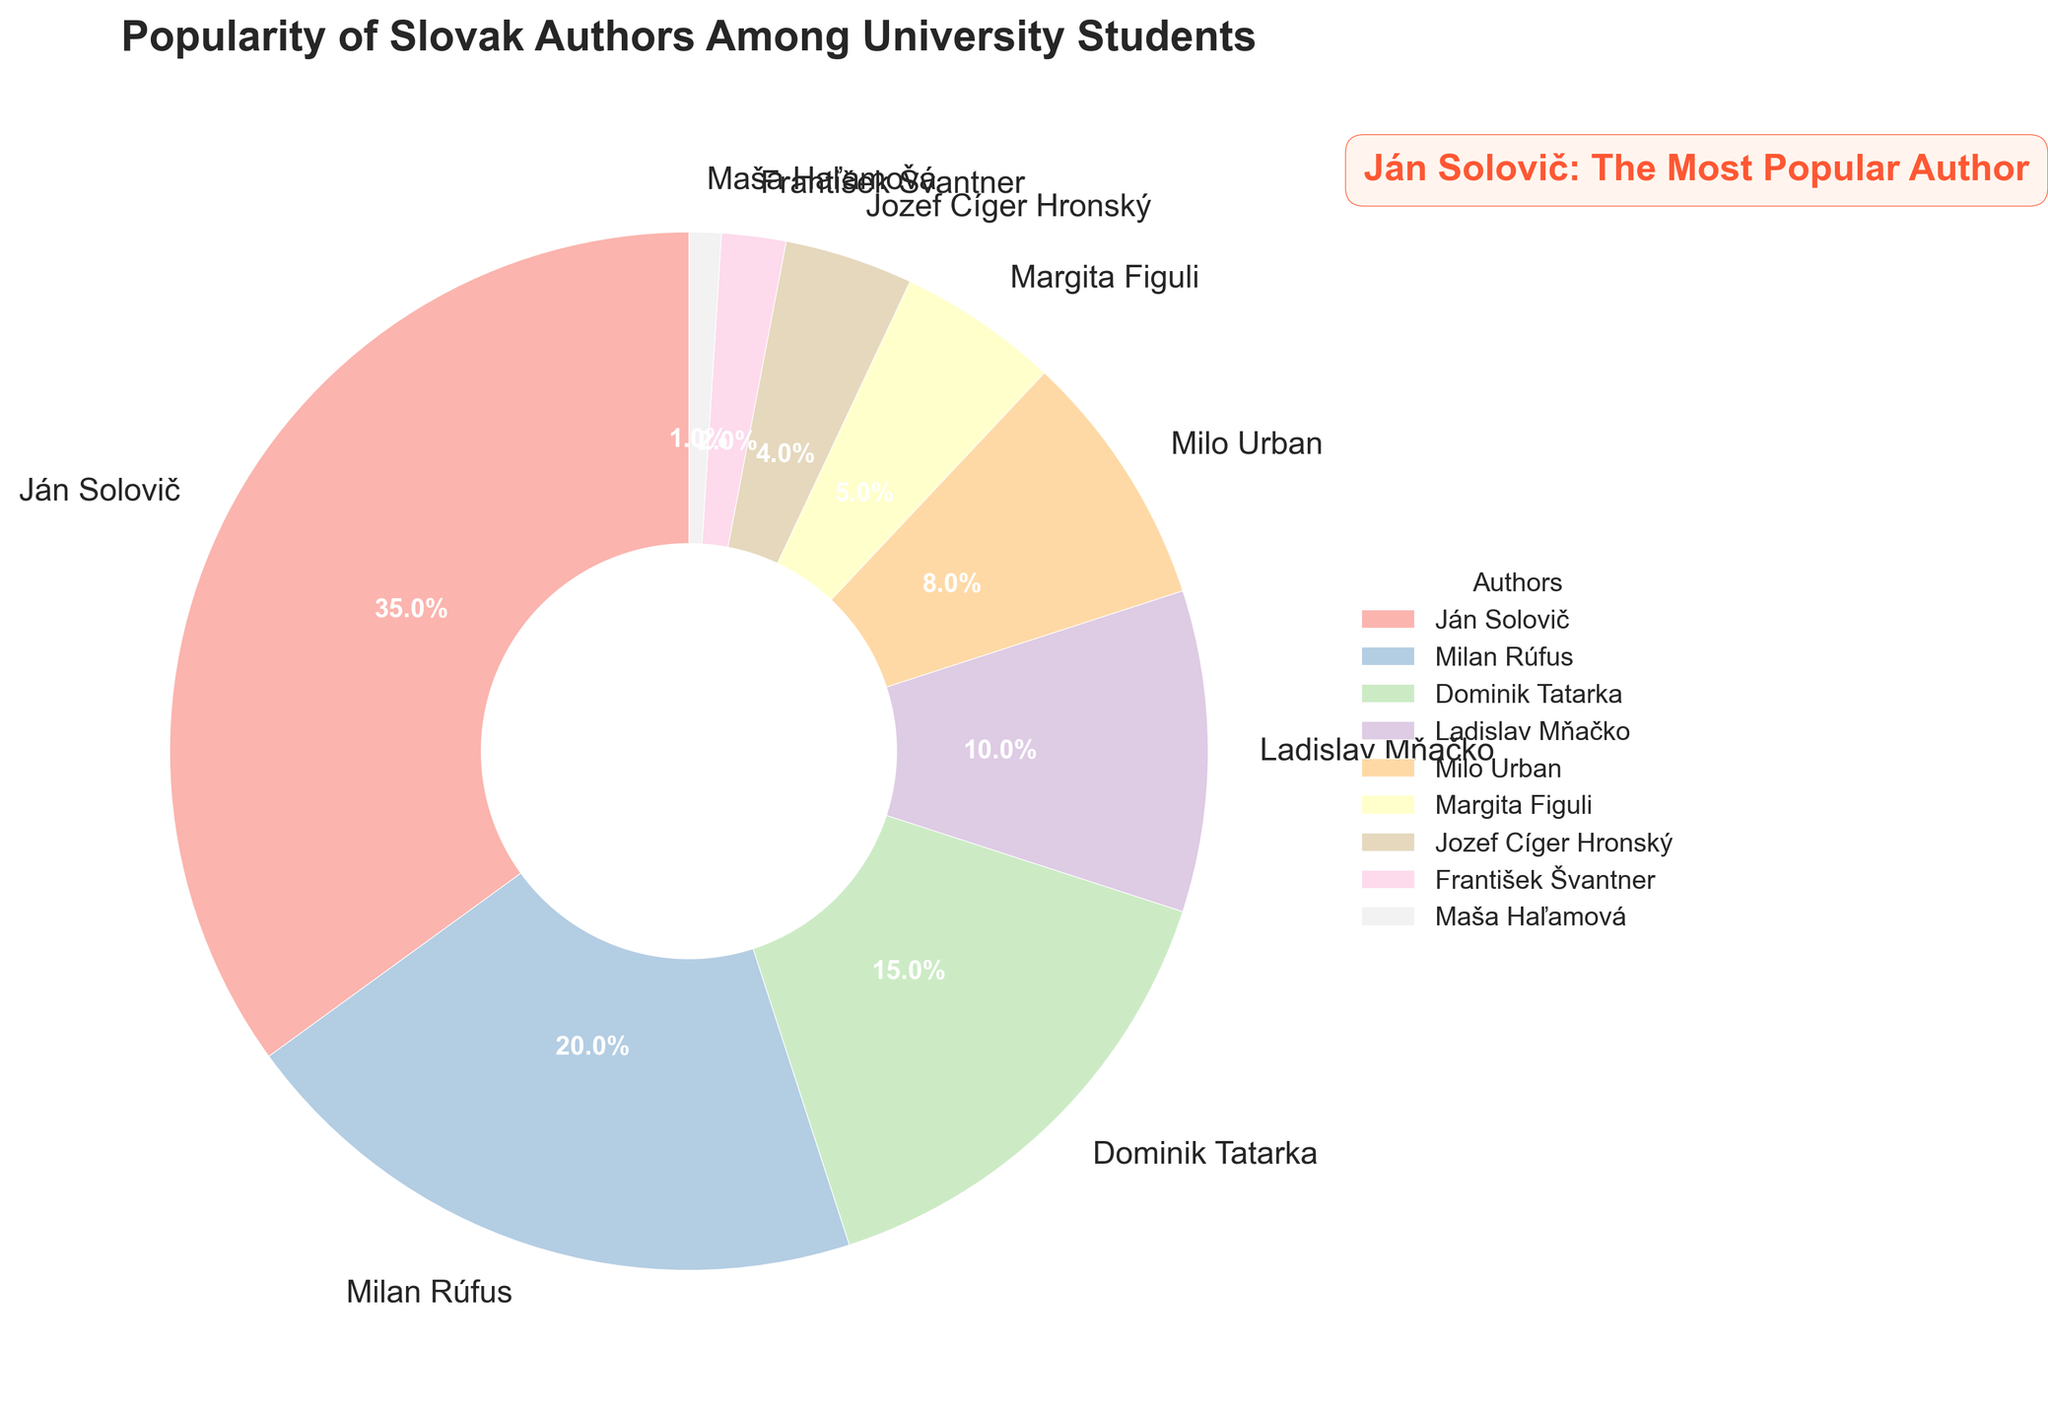What percentage of students prefer Ján Solovič? Ján Solovič has a wedge in the pie chart labeled with "35%", indicating that 35% of students prefer him.
Answer: 35% Who is the second most popular Slovak author among university students? The wedge with the next highest percentage after Ján Solovič is labeled "Milan Rúfus" with 20%.
Answer: Milan Rúfus What percentage of students prefer either Ján Solovič or Milan Rúfus? Add the percentages for Ján Solovič (35%) and Milan Rúfus (20%): 35% + 20% = 55%.
Answer: 55% How much more popular is Ján Solovič compared to Milo Urban? Ján Solovič has 35% and Milo Urban has 8%. The difference is 35% - 8% = 27%.
Answer: 27% Which author has the least popularity among students? The smallest wedge is labeled "Maša Haľamová" with 1%.
Answer: Maša Haľamová What is the combined popularity percentage of Dominik Tatarka and Ladislav Mňačko? Add the percentages for Dominik Tatarka (15%) and Ladislav Mňačko (10%): 15% + 10% = 25%.
Answer: 25% Compare the popularity of Ján Solovič and František Švantner. Ján Solovič has 35%, while František Švantner has 2%. Ján Solovič is significantly more popular.
Answer: Ján Solovič is more popular How much more popular is Milan Rúfus compared to Margita Figuli? Milan Rúfus has 20% and Margita Figuli has 5%. The difference is 20% - 5% = 15%.
Answer: 15% What is the total percentage of popularity for authors with less than 10%? Add the percentages for Ladislav Mňačko (10%), Milo Urban (8%), Margita Figuli (5%), Jozef Cíger Hronský (4%), František Švantner (2%), Maša Haľamová (1%): 10% + 8% + 5% + 4% + 2% + 1% = 30%.
Answer: 30% What is the visual characteristic used to emphasize Ján Solovič in the title? The title features the phrase "Ján Solovič: The Most Popular Author" highlighted with a bold, larger font in a contrasting color.
Answer: Bold, larger font in a contrasting color 